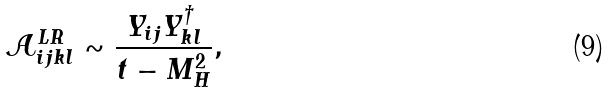<formula> <loc_0><loc_0><loc_500><loc_500>\mathcal { A } ^ { L R } _ { i j k l } \sim \frac { Y _ { i j } Y _ { k l } ^ { \dagger } } { t - M _ { H } ^ { 2 } } ,</formula> 